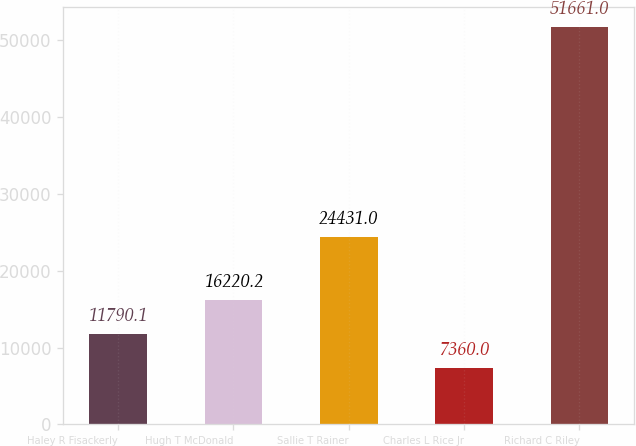Convert chart. <chart><loc_0><loc_0><loc_500><loc_500><bar_chart><fcel>Haley R Fisackerly<fcel>Hugh T McDonald<fcel>Sallie T Rainer<fcel>Charles L Rice Jr<fcel>Richard C Riley<nl><fcel>11790.1<fcel>16220.2<fcel>24431<fcel>7360<fcel>51661<nl></chart> 